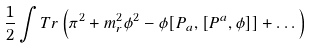Convert formula to latex. <formula><loc_0><loc_0><loc_500><loc_500>\frac { 1 } { 2 } \int T r \left ( \pi ^ { 2 } + m _ { r } ^ { 2 } \phi ^ { 2 } - \phi [ P _ { a } , [ P ^ { a } , \phi ] ] + \dots \right )</formula> 